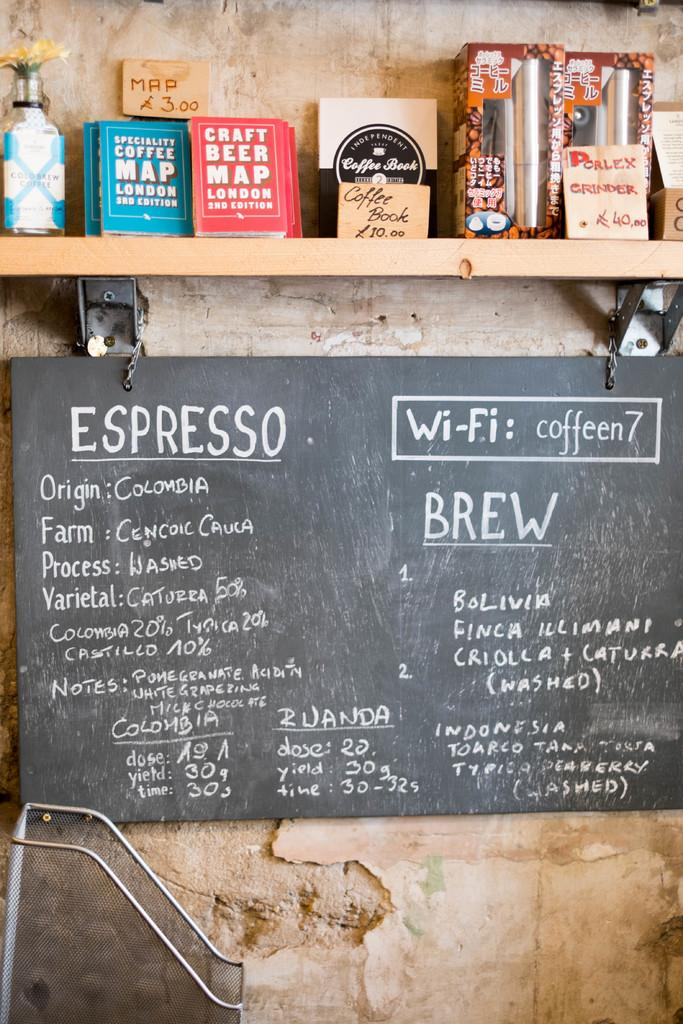<image>
Summarize the visual content of the image. A chalk board shows where the espresso comes from. 